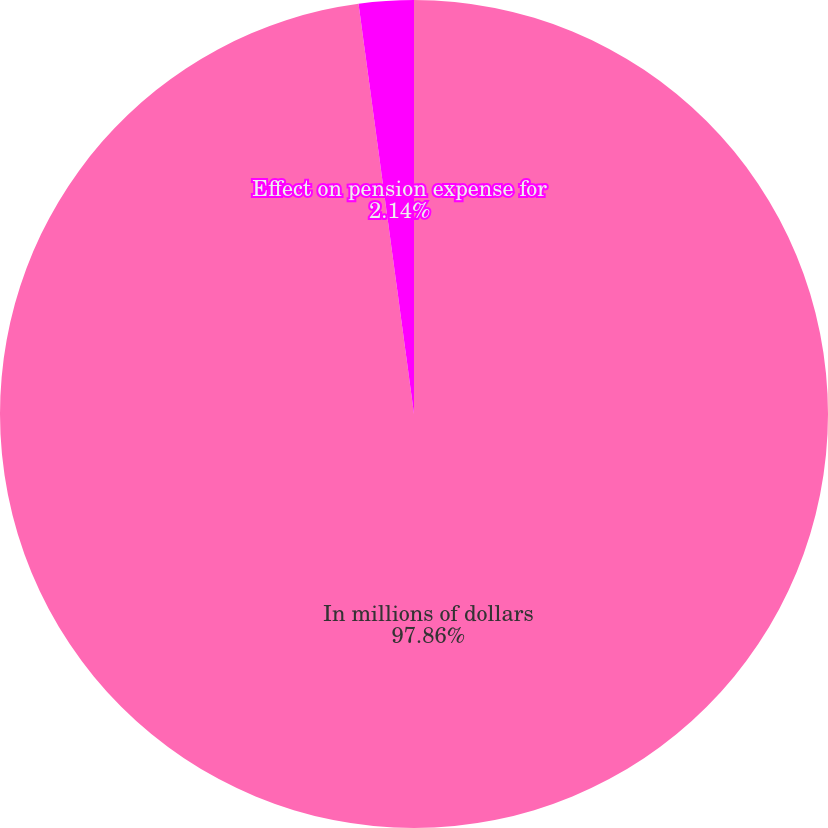<chart> <loc_0><loc_0><loc_500><loc_500><pie_chart><fcel>In millions of dollars<fcel>Effect on pension expense for<nl><fcel>97.86%<fcel>2.14%<nl></chart> 